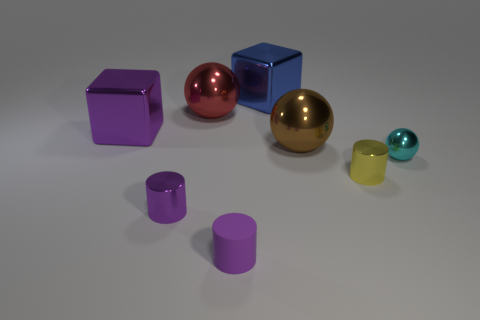Add 1 small spheres. How many objects exist? 9 Subtract all cylinders. How many objects are left? 5 Subtract 0 yellow cubes. How many objects are left? 8 Subtract all red shiny cylinders. Subtract all tiny cyan metal objects. How many objects are left? 7 Add 5 yellow objects. How many yellow objects are left? 6 Add 8 small green cylinders. How many small green cylinders exist? 8 